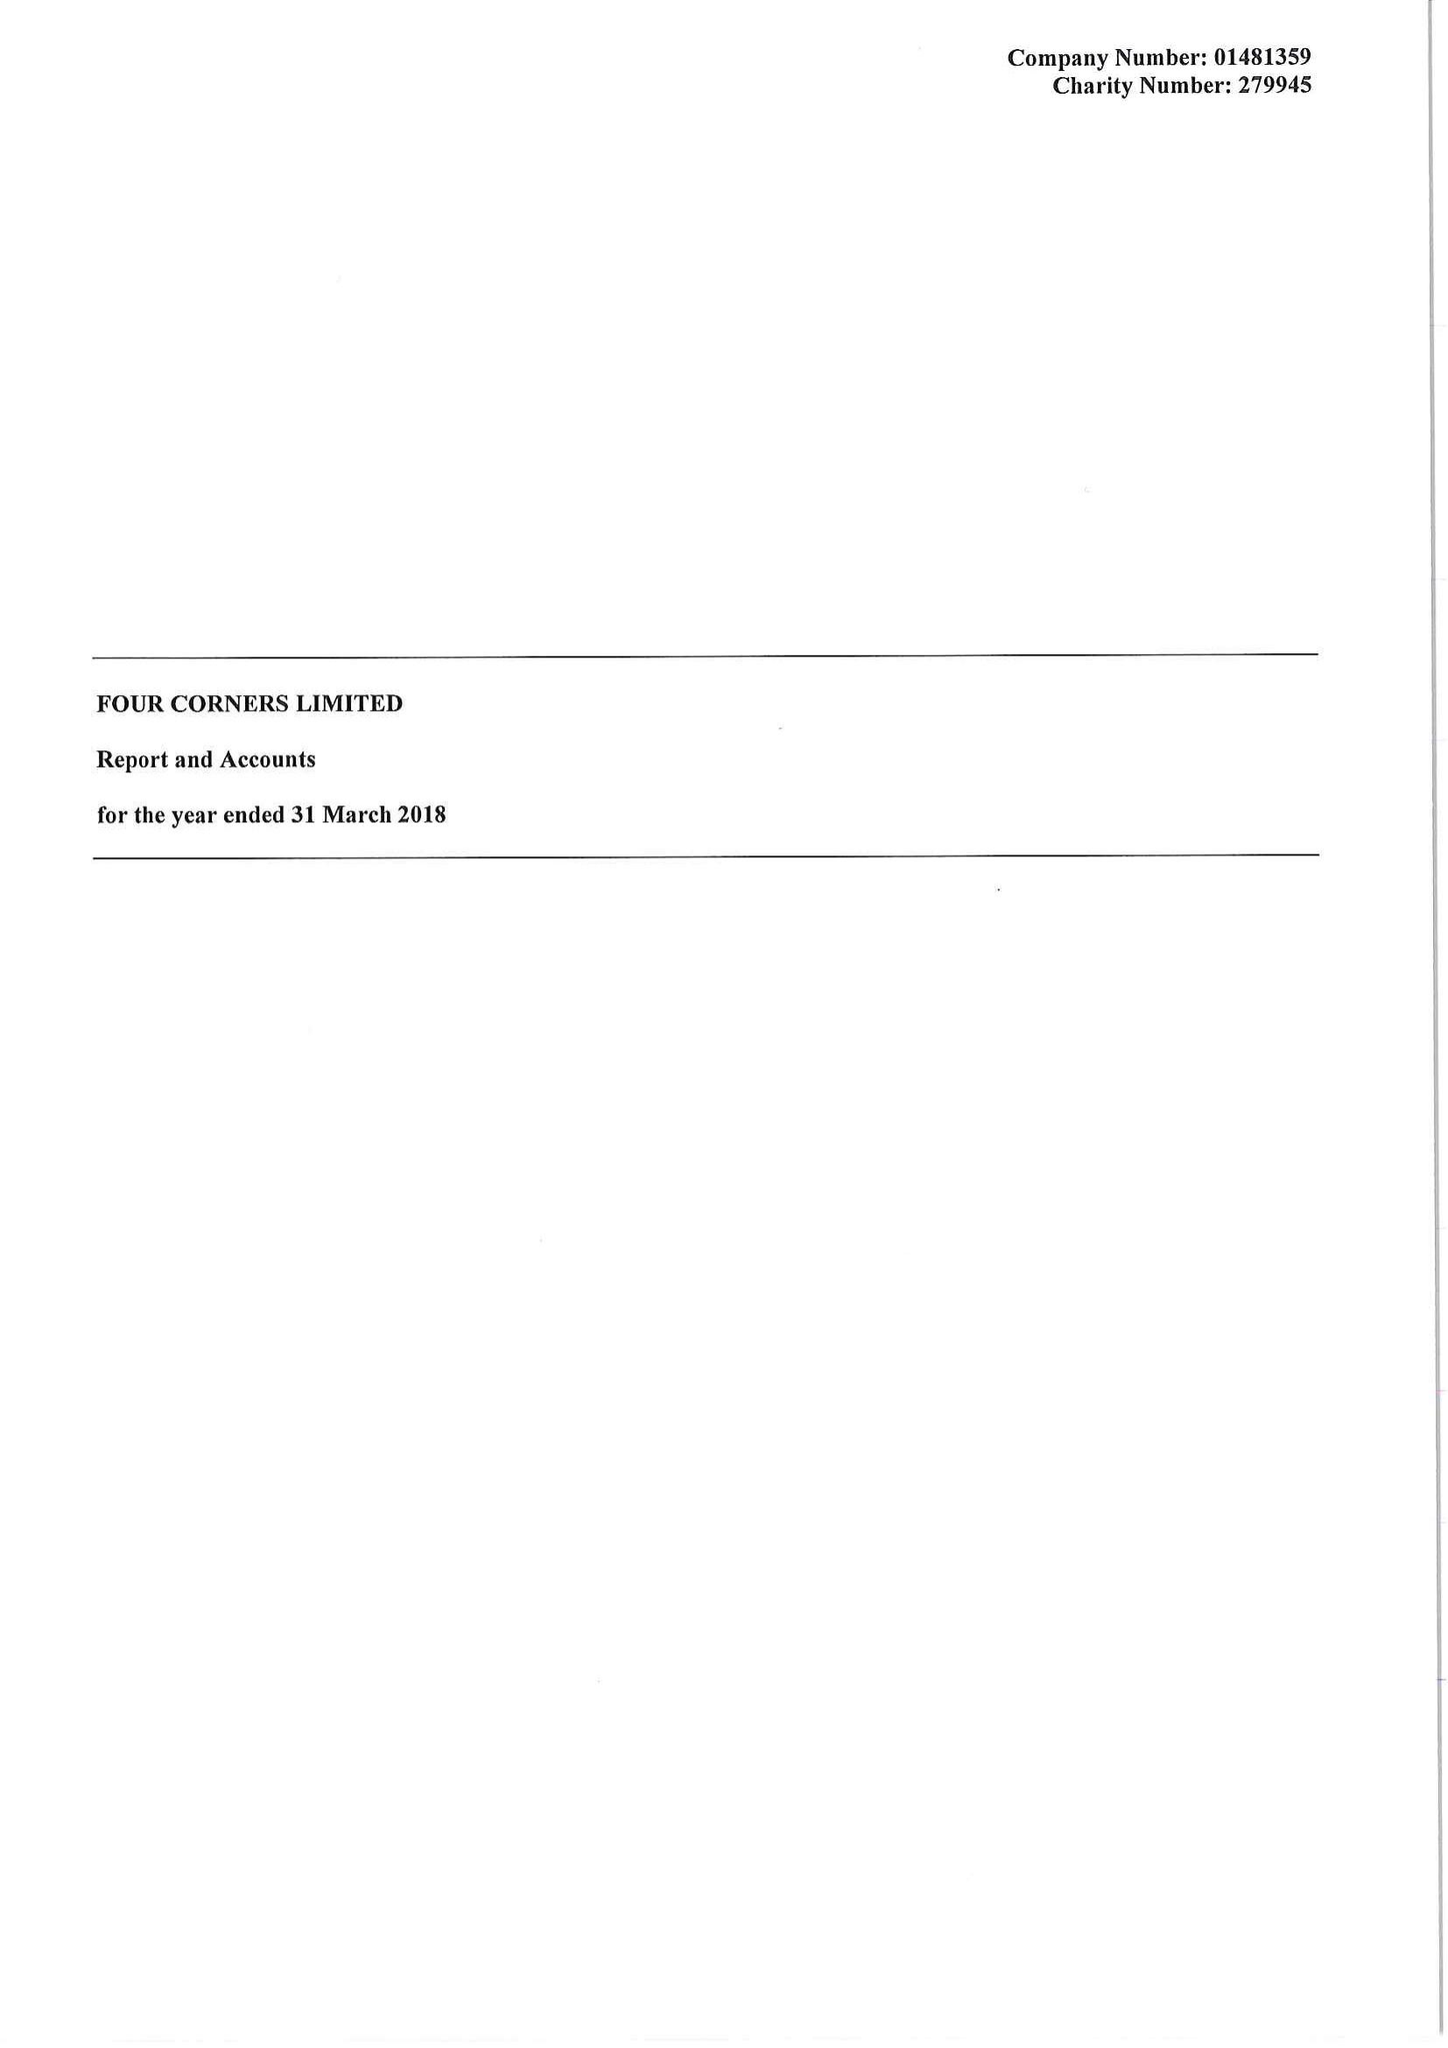What is the value for the address__postcode?
Answer the question using a single word or phrase. E2 0QN 